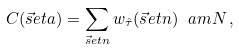<formula> <loc_0><loc_0><loc_500><loc_500>C ( \vec { s } e t a ) = \sum _ { \vec { s } e t n } w _ { \hat { \tau } } ( \vec { s } e t n ) \ a m N \, ,</formula> 